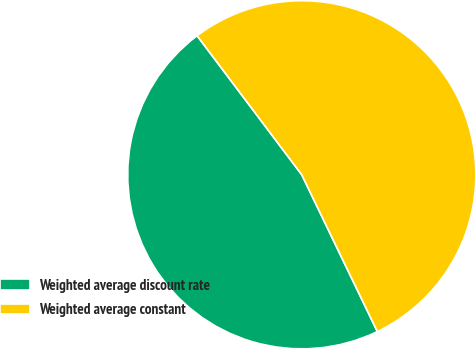Convert chart. <chart><loc_0><loc_0><loc_500><loc_500><pie_chart><fcel>Weighted average discount rate<fcel>Weighted average constant<nl><fcel>46.88%<fcel>53.12%<nl></chart> 